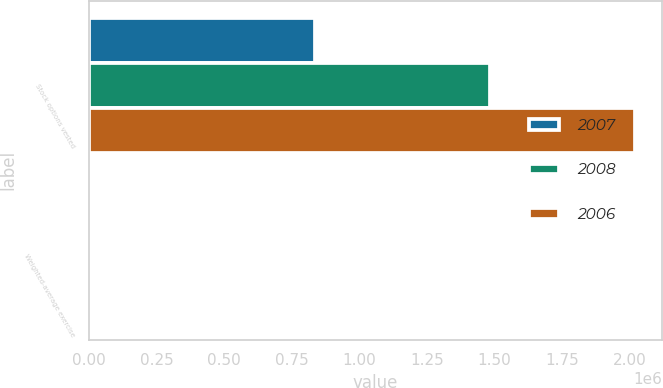<chart> <loc_0><loc_0><loc_500><loc_500><stacked_bar_chart><ecel><fcel>Stock options vested<fcel>Weighted-average exercise<nl><fcel>2007<fcel>835982<fcel>47.21<nl><fcel>2008<fcel>1.48473e+06<fcel>47.05<nl><fcel>2006<fcel>2.02005e+06<fcel>40.8<nl></chart> 